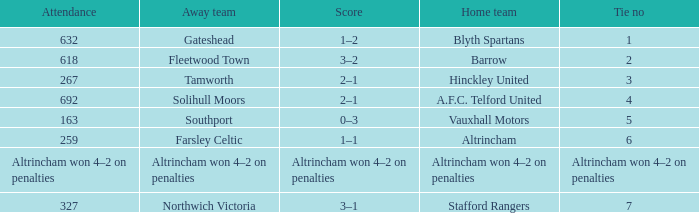What was the score at the time of 7 ties? 3–1. 